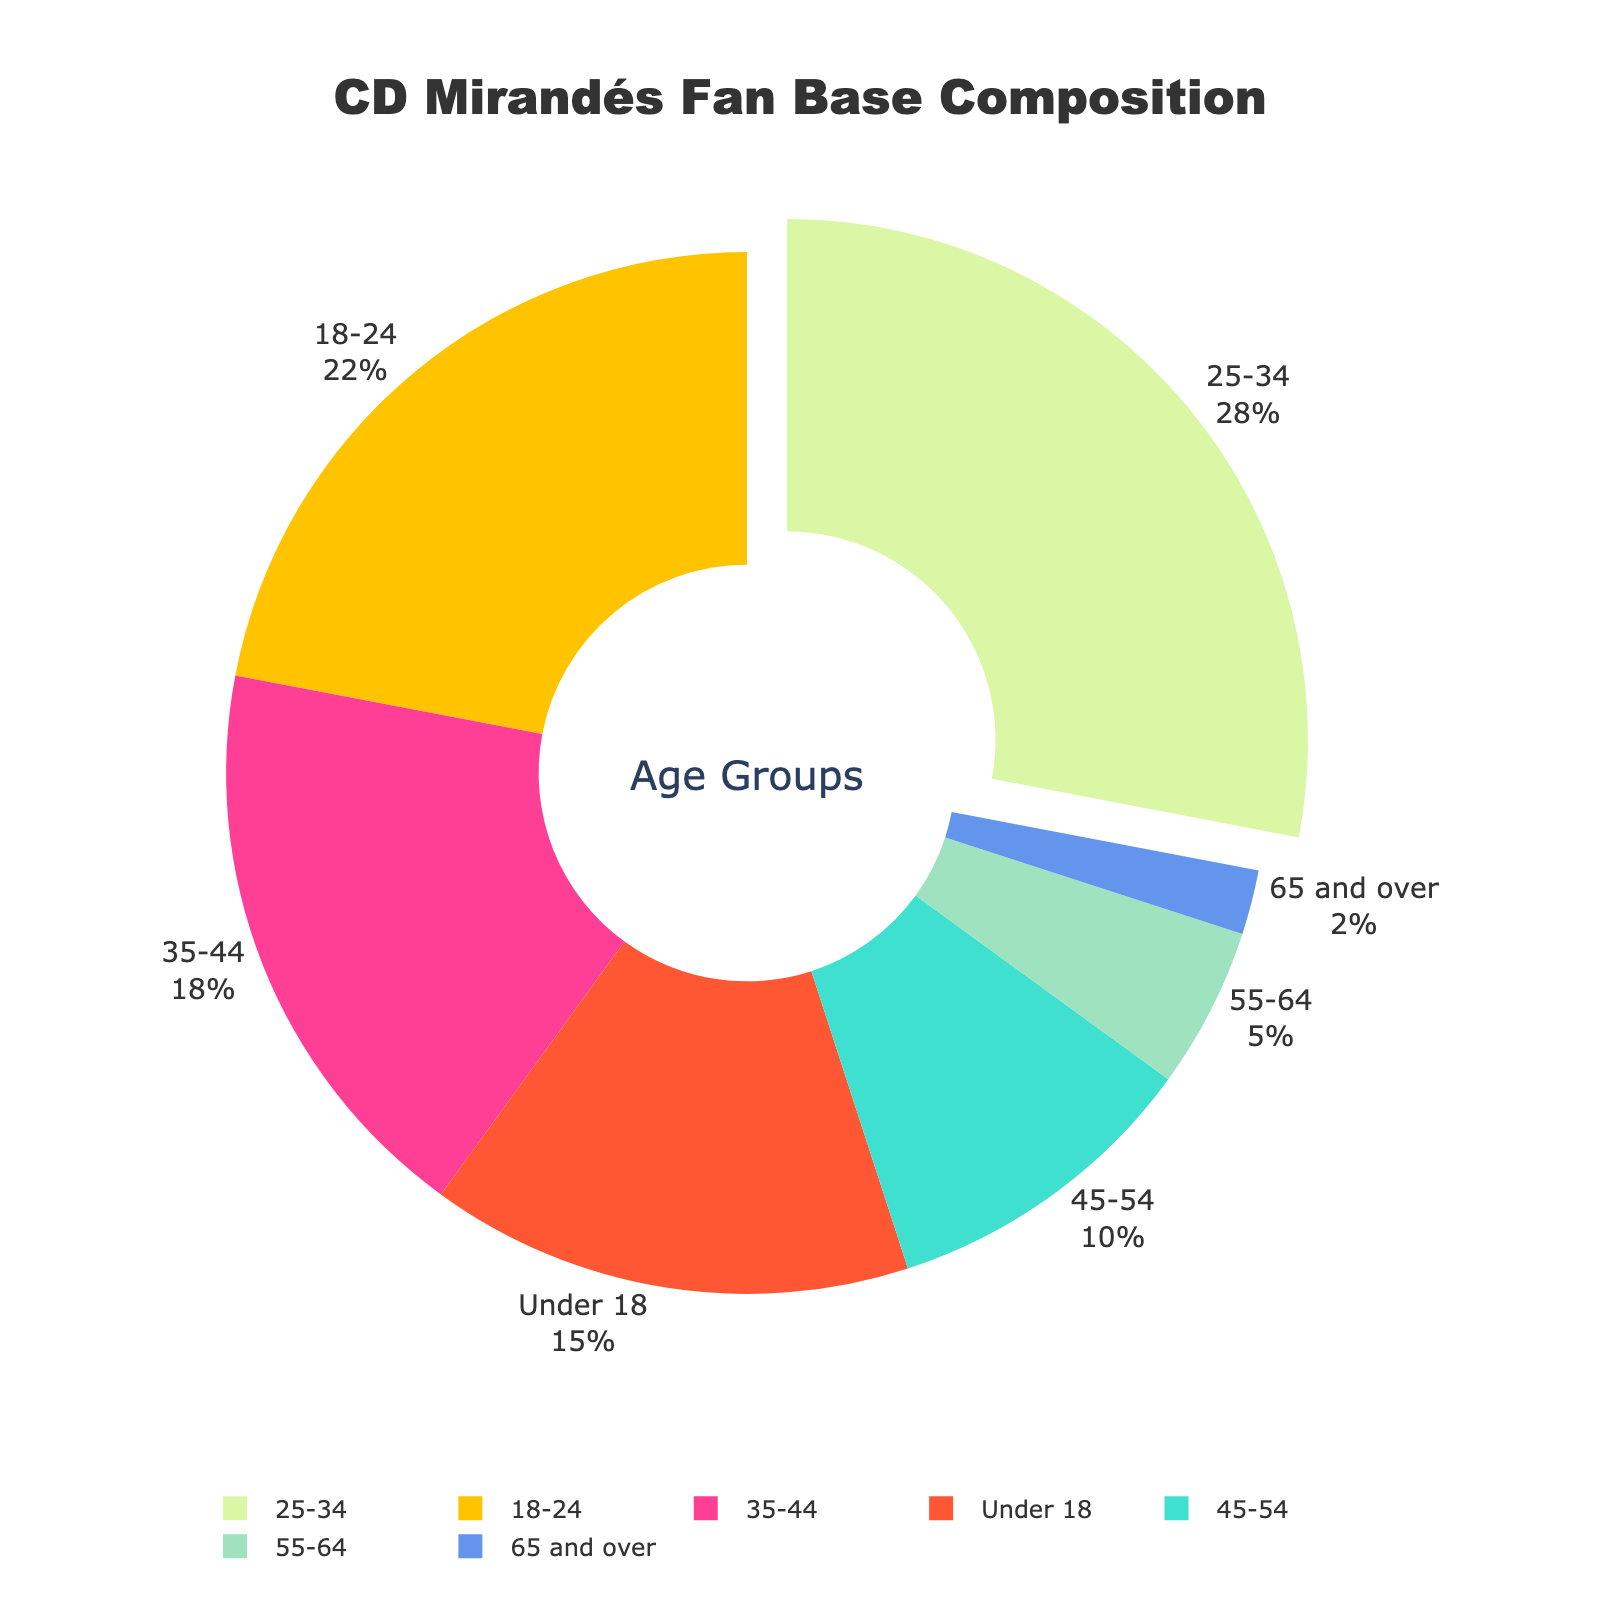What's the most represented age group in the CD Mirandés fan base? The chart uses a pie chart to show a 28% segment for the 25-34 age group, which is larger than any other group.
Answer: 25-34 Which age group makes up the smallest portion of the fan base? The smallest slice of the pie chart is 2%, corresponding to the 65 and over age group.
Answer: 65 and over How many percentage points larger is the 25-34 age group compared to the 45-54 age group? The 25-34 age group is 28% and the 45-54 age group is 10%. The difference is 28% - 10% = 18 percentage points.
Answer: 18 percentage points Which age groups together make up more than 50% of the fan base? The 25-34 age group is 28%, the 18-24 age group is 22%, and 28% + 22% = 50%. Therefore, the 18-24 and 25-34 age groups together make up more than 50%.
Answer: 18-24 and 25-34 What percentage of the fan base is aged 35 and over? Sum the percentages of the age groups 35-44 (18%), 45-54 (10%), 55-64 (5%), and 65 and over (2%). The calculation is 18% + 10% + 5% + 2% = 35%.
Answer: 35% Is the percentage of fans under 18 greater than the percentage of fans aged 35-44? Fans under 18 make up 15%, and fans aged 35-44 make up 18%. 15% is less than 18%.
Answer: No How does the percentage of fans in the 18-24 age group compare to the percentage in the 55-64 age group? Fans aged 18-24 represent 22%, while fans aged 55-64 make up 5%. 22% is greater than 5%.
Answer: 18-24 is greater Which age group is represented by the green section of the pie chart? The pie chart colors include green, representing a 5% section. From the data, the 55-64 age group makes up 5%.
Answer: 55-64 What percentage of the fan base is younger than 35? Sum the percentages of the age groups Under 18 (15%), 18-24 (22%), and 25-34 (28%). The calculation is 15% + 22% + 28% = 65%.
Answer: 65% 